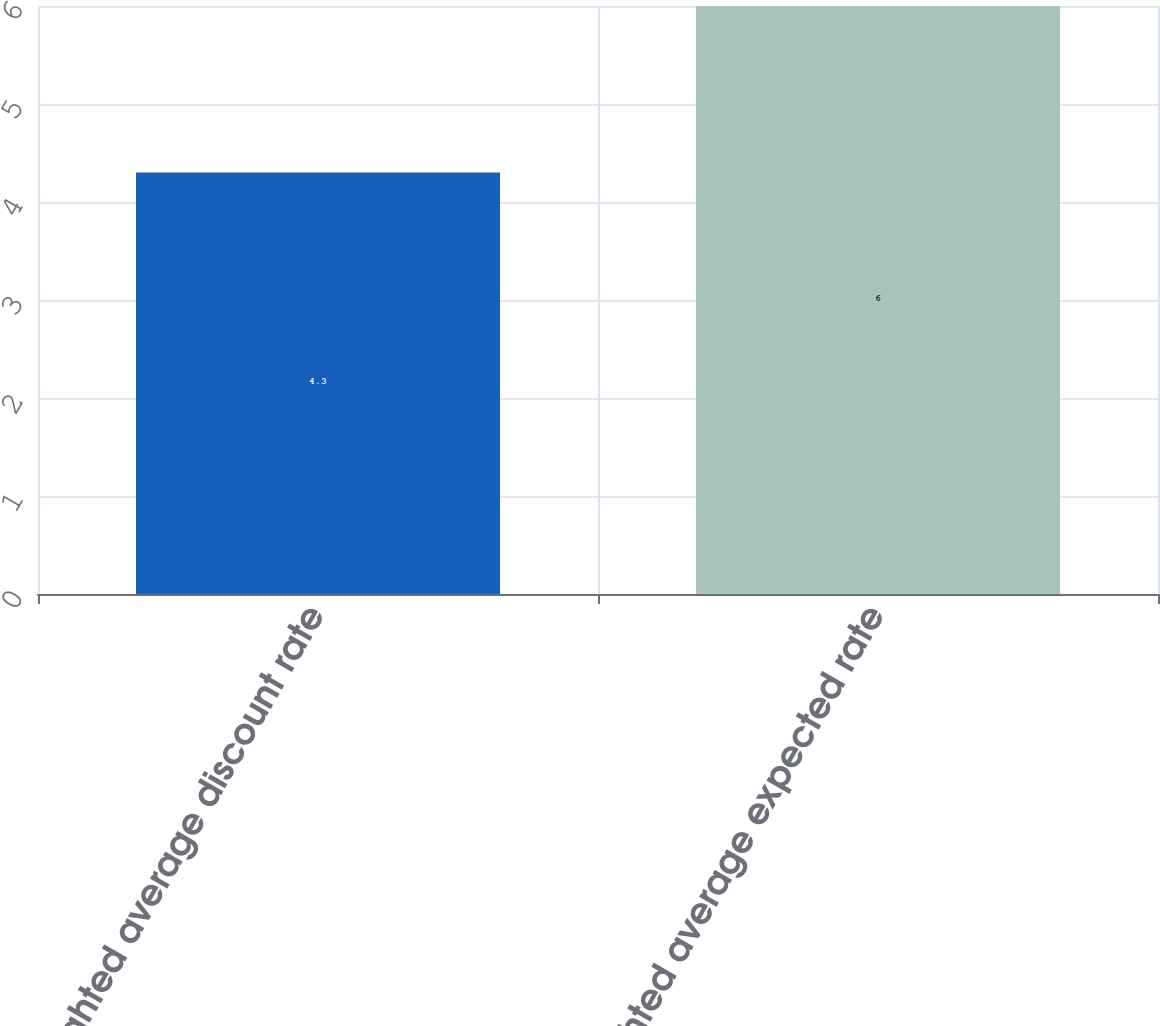Convert chart to OTSL. <chart><loc_0><loc_0><loc_500><loc_500><bar_chart><fcel>Weighted average discount rate<fcel>Weighted average expected rate<nl><fcel>4.3<fcel>6<nl></chart> 